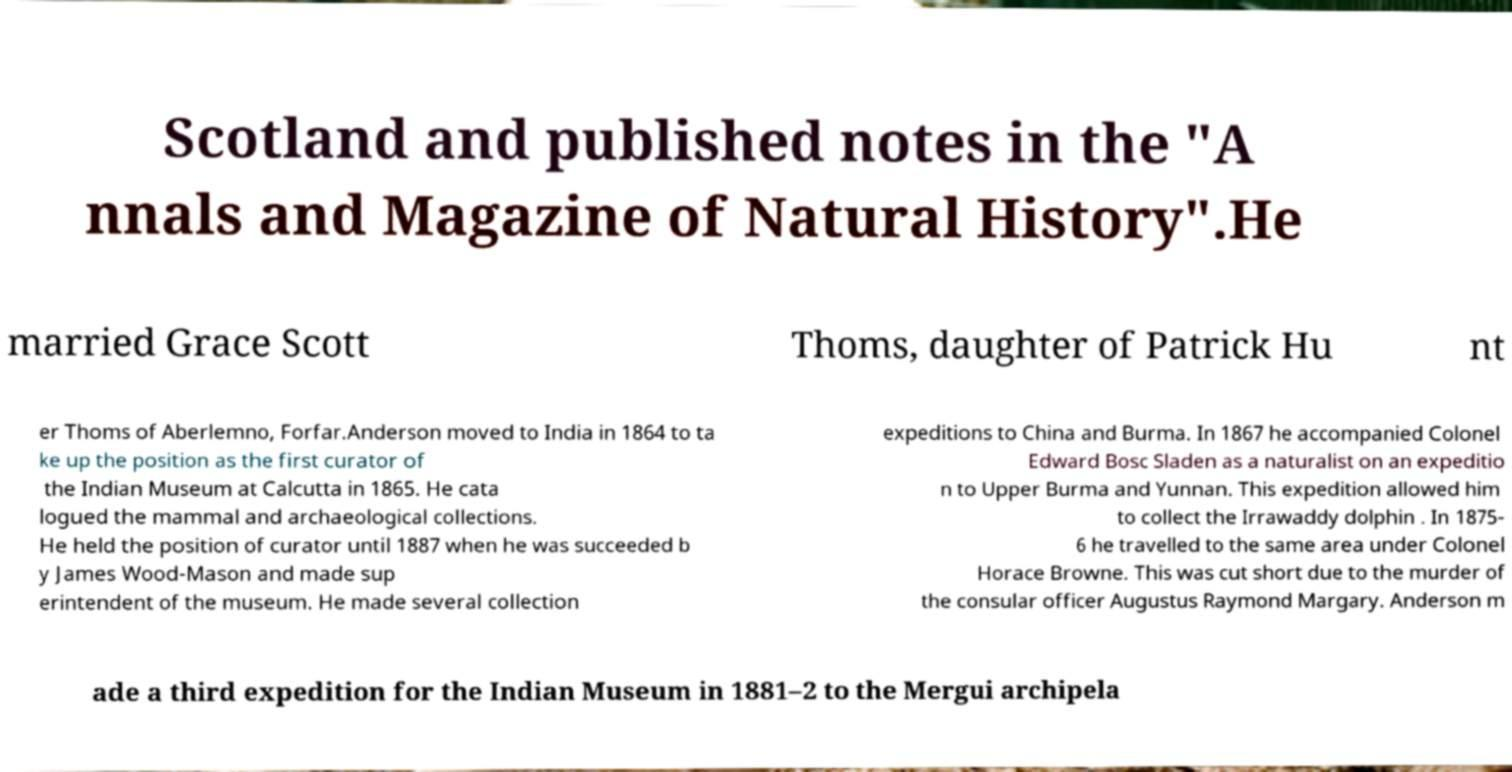I need the written content from this picture converted into text. Can you do that? Scotland and published notes in the "A nnals and Magazine of Natural History".He married Grace Scott Thoms, daughter of Patrick Hu nt er Thoms of Aberlemno, Forfar.Anderson moved to India in 1864 to ta ke up the position as the first curator of the Indian Museum at Calcutta in 1865. He cata logued the mammal and archaeological collections. He held the position of curator until 1887 when he was succeeded b y James Wood-Mason and made sup erintendent of the museum. He made several collection expeditions to China and Burma. In 1867 he accompanied Colonel Edward Bosc Sladen as a naturalist on an expeditio n to Upper Burma and Yunnan. This expedition allowed him to collect the Irrawaddy dolphin . In 1875- 6 he travelled to the same area under Colonel Horace Browne. This was cut short due to the murder of the consular officer Augustus Raymond Margary. Anderson m ade a third expedition for the Indian Museum in 1881–2 to the Mergui archipela 